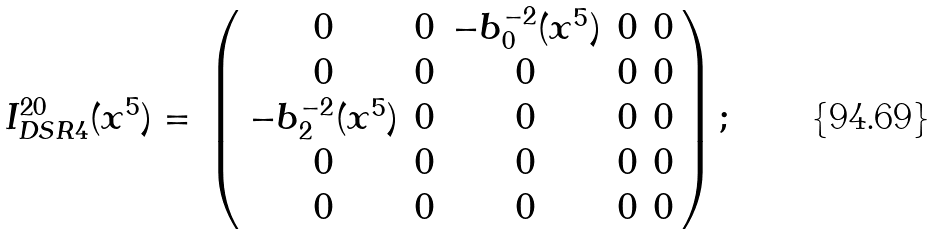Convert formula to latex. <formula><loc_0><loc_0><loc_500><loc_500>\begin{array} { c c } I _ { D S R 4 } ^ { 2 0 } ( x ^ { 5 } ) = & \left ( \begin{array} { c c c c c } 0 & 0 & - b _ { 0 } ^ { - 2 } ( x ^ { 5 } ) & 0 & 0 \\ 0 & 0 & 0 & 0 & 0 \\ - b _ { 2 } ^ { - 2 } ( x ^ { 5 } ) & 0 & 0 & 0 & 0 \\ 0 & 0 & 0 & 0 & 0 \\ 0 & 0 & 0 & 0 & 0 \end{array} \right ) ; \end{array}</formula> 